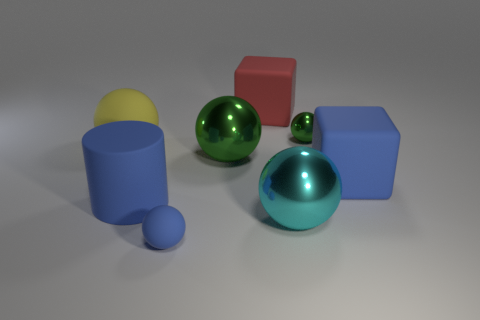What textures are present in the materials shown? In the image, we notice a contrast in textures. The surfaces of the blue cylinder, small blue sphere, red cube, and blue rectangular prism exhibit a matte finish with soft diffuse reflections, indicating a somewhat rough or non-glossy texture. On the other hand, the green and teal metallic spheres display a shiny, smooth texture with sharp, clear reflections, suggesting a more polished or glossier material. 